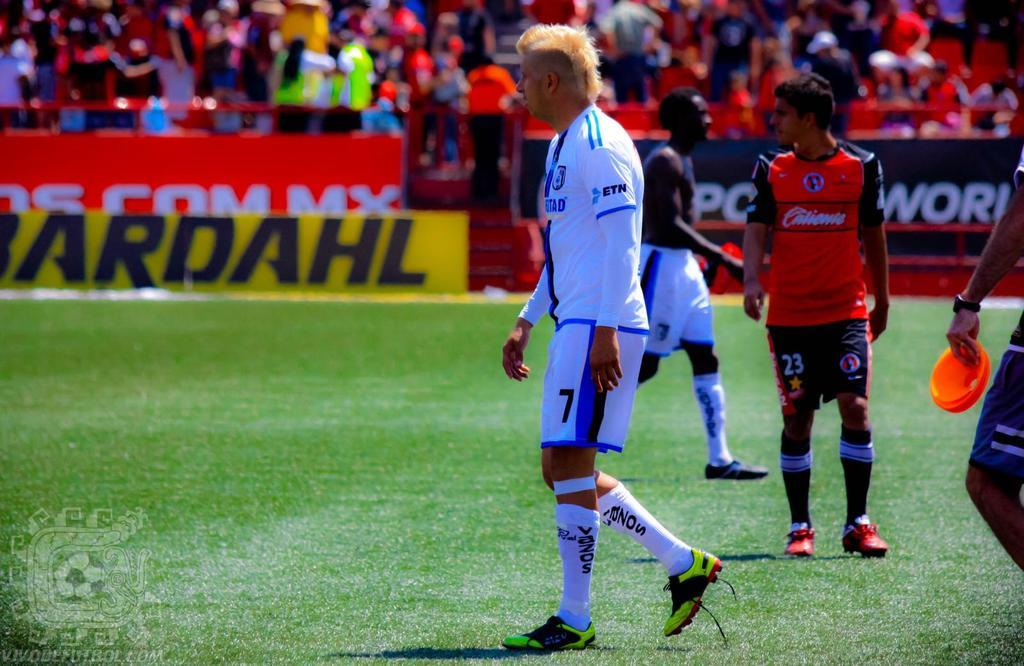<image>
Render a clear and concise summary of the photo. a group of players with Bardahl on a banner on the sidelines. 